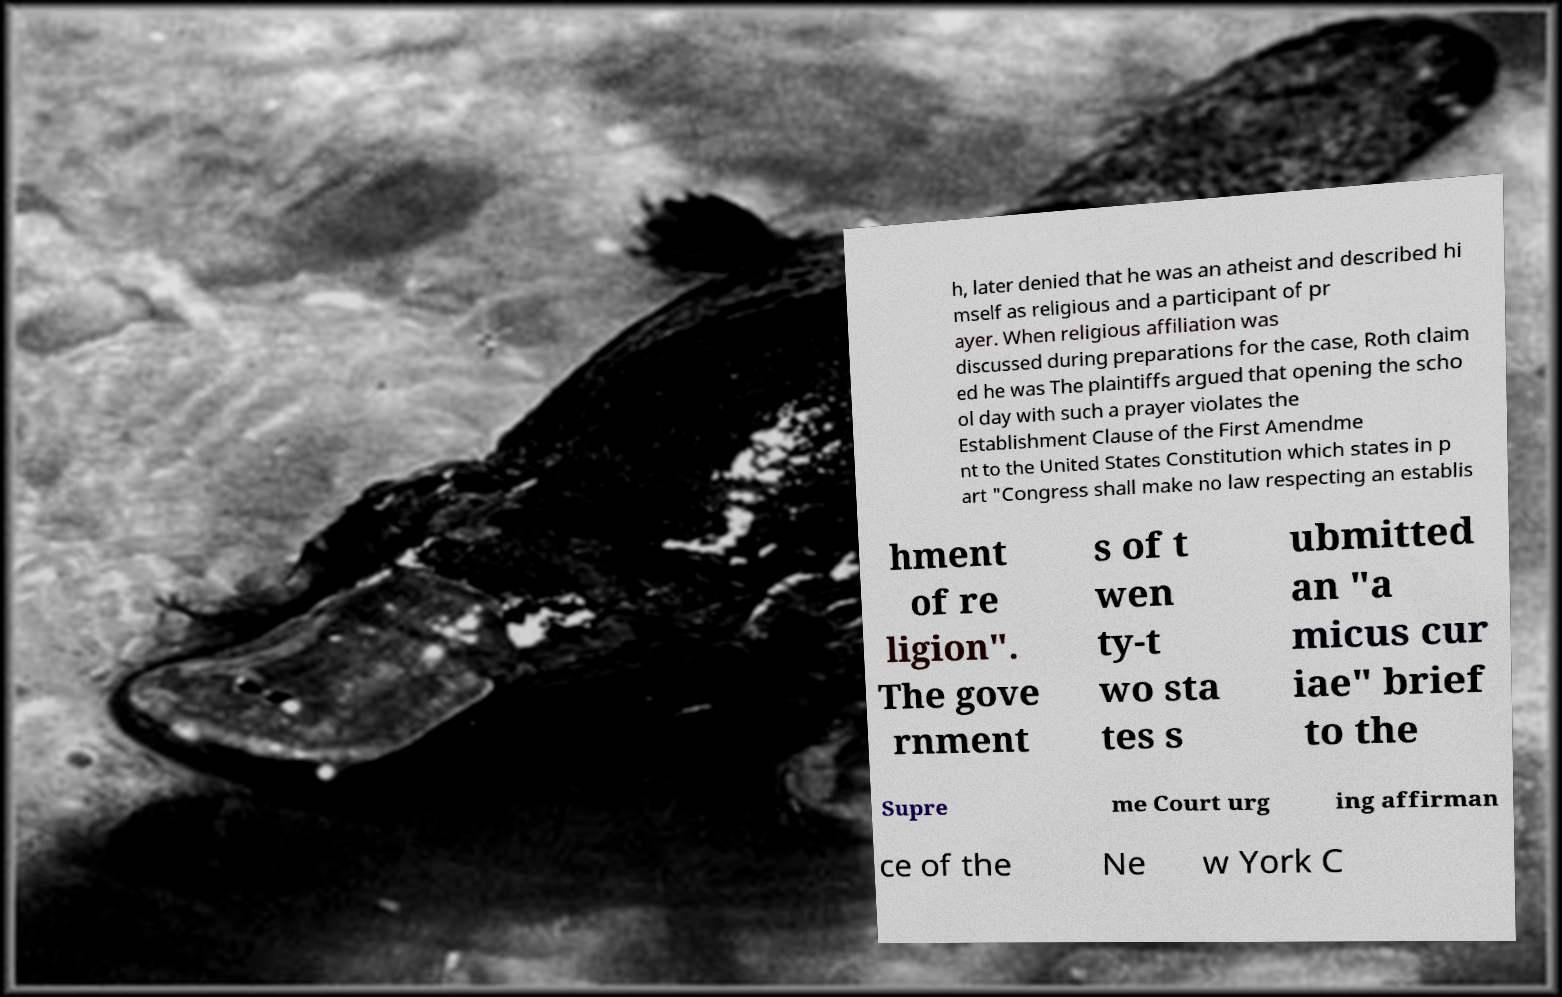Please identify and transcribe the text found in this image. h, later denied that he was an atheist and described hi mself as religious and a participant of pr ayer. When religious affiliation was discussed during preparations for the case, Roth claim ed he was The plaintiffs argued that opening the scho ol day with such a prayer violates the Establishment Clause of the First Amendme nt to the United States Constitution which states in p art "Congress shall make no law respecting an establis hment of re ligion". The gove rnment s of t wen ty-t wo sta tes s ubmitted an "a micus cur iae" brief to the Supre me Court urg ing affirman ce of the Ne w York C 